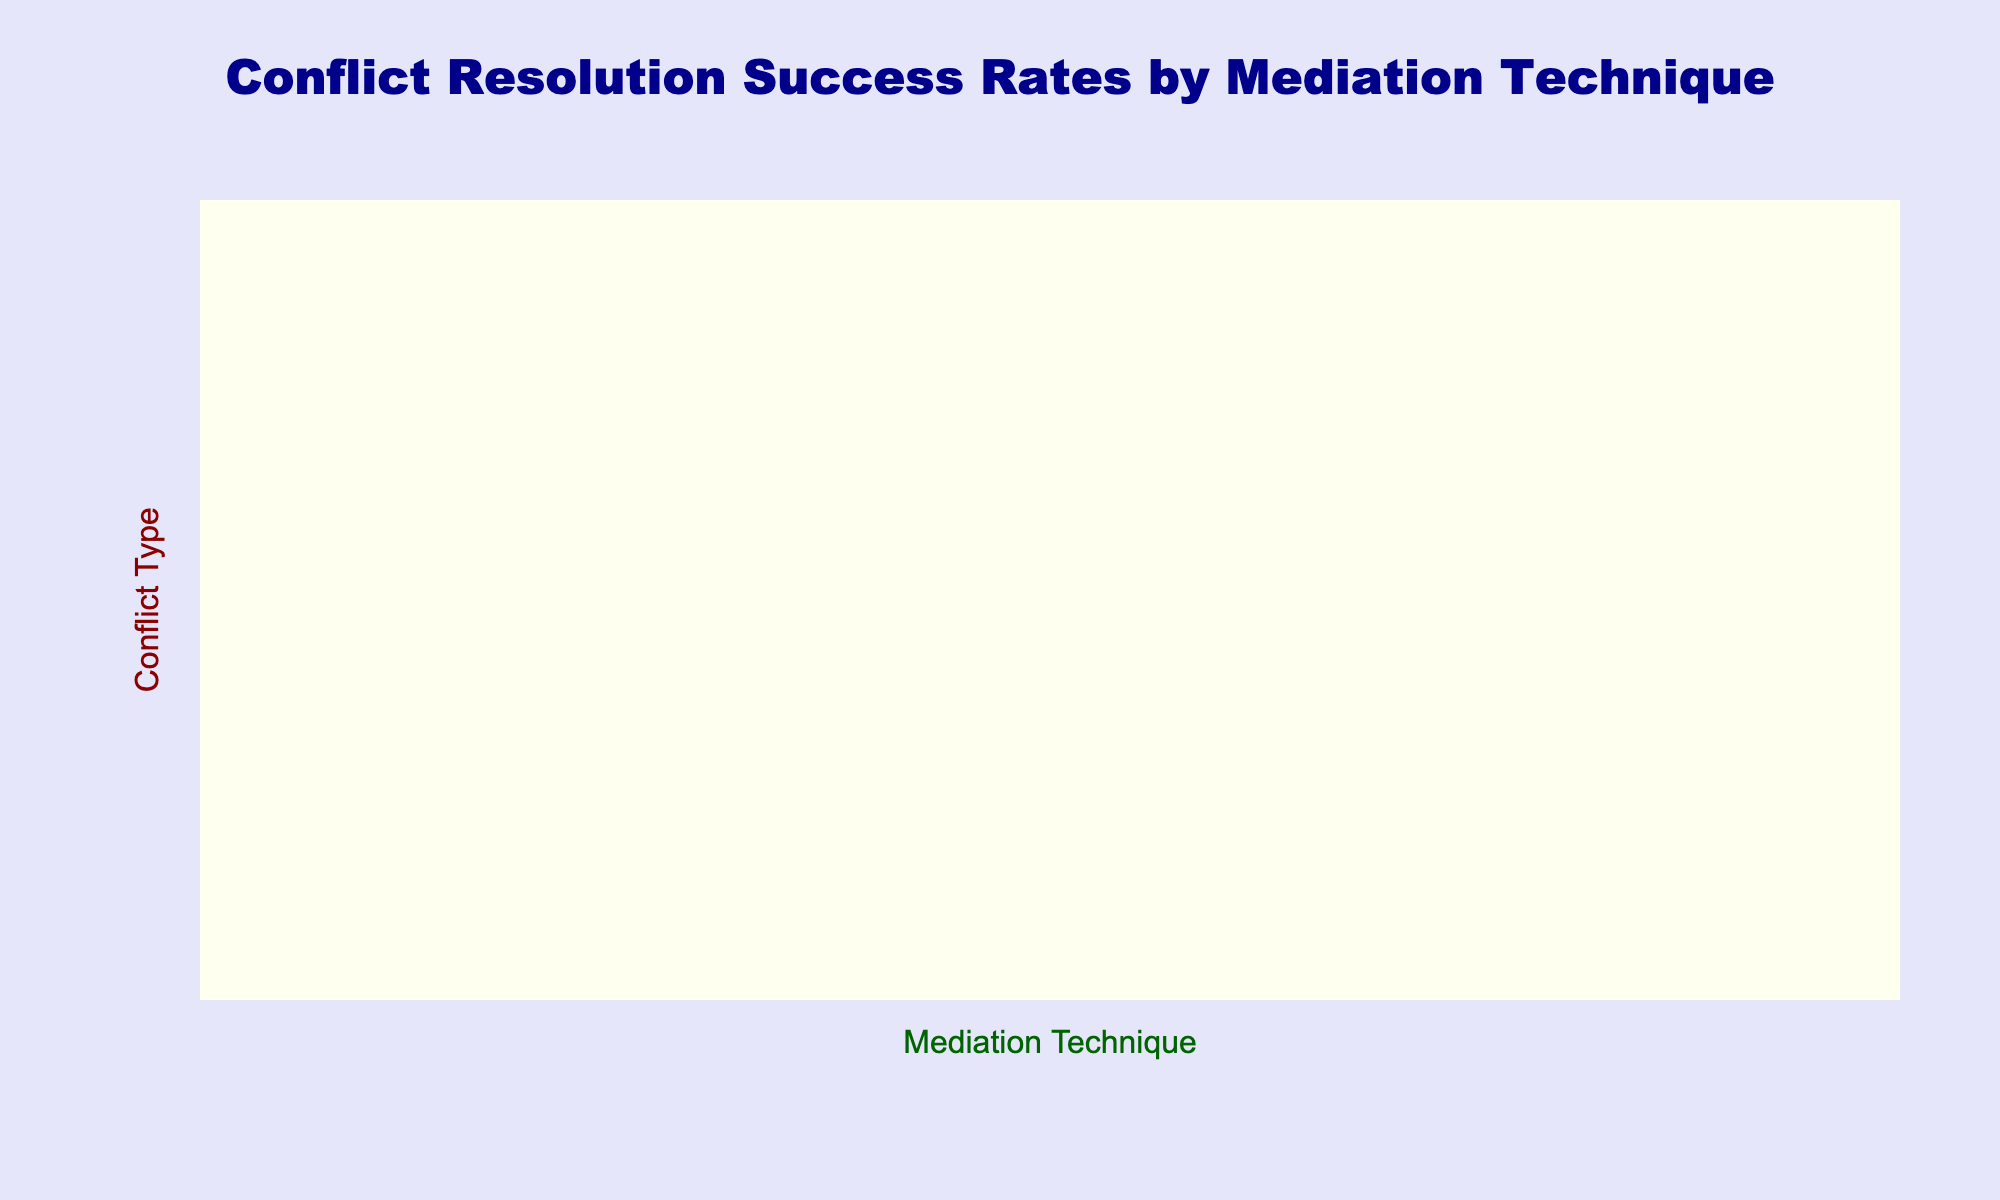What is the highest success rate and which mediation technique corresponds to it? The highest success rate in the table is 85%. It is seen in two conflict types: Youth Gang Conflicts and Post-Conflict Reintegration, with the mediation technique of Narrative Mediation being effective for both.
Answer: 85%, Narrative Mediation Which mediation technique had the lowest success rate dealing with Political Reconciliation? The lowest success rate for Political Reconciliation is for Youth Gang Conflicts with a value of 50%, which corresponds to the mediation technique of Shuttle Diplomacy.
Answer: Shuttle Diplomacy, 50% What is the average success rate for Community Dialogue across all conflict types? The success rates for Community Dialogue are 75%, 65%, 70%, 60%, 80%, 68%, and 72%. Summing these yields 75 + 65 + 70 + 60 + 80 + 68 + 72 = 490. Since there are 7 values, the average is 490/7 ≈ 70%.
Answer: 70% Is the success rate for Transformative Mediation in Intra-Community Disputes higher than that for Inter-Ethnic Conflicts? The success rate for Transformative Mediation in Intra-Community Disputes is 80%, while for Inter-Ethnic Conflicts it is 72%. Since 80% is greater than 72%, the statement is true.
Answer: Yes Which mediation technique showed consistent success rates above 70% for all conflict types? Examining the table, the mediation technique of Narrative Mediation has the following success rates: 65%, 70%, 60%, 75%, 85%, 80%, and 75%. It has three rates below 70%; thus, this condition is not met. However, the technique with consistent rates is Community Dialogue in most cases.
Answer: No What is the difference in success rates between Problem-Solving Workshops and Shuttle Diplomacy for Land Ownership Disputes? For Land Ownership Disputes, the success rate for Problem-Solving Workshops is 85%, while for Shuttle Diplomacy, it is 55%. The difference is calculated as 85 - 55 = 30%.
Answer: 30% What mediation technique had the most effective success rate for Youth Gang Conflicts? The success rates for Youth Gang Conflicts are: Community Dialogue at 80%, Shuttle Diplomacy at 50%, Problem-Solving Workshops at 75%, Narrative Mediation at 85%, and Transformative Mediation at 78%. The highest rate is 85% with Narrative Mediation.
Answer: Narrative Mediation, 85% Which conflict type has the highest success rate with any mediation technique, and what is that rate? Looking at the highest values, we see Youth Gang Conflicts with Narrative Mediation at 85%. No other conflict type with any mediation technique exceeds this, making it the highest.
Answer: Youth Gang Conflicts, 85% 